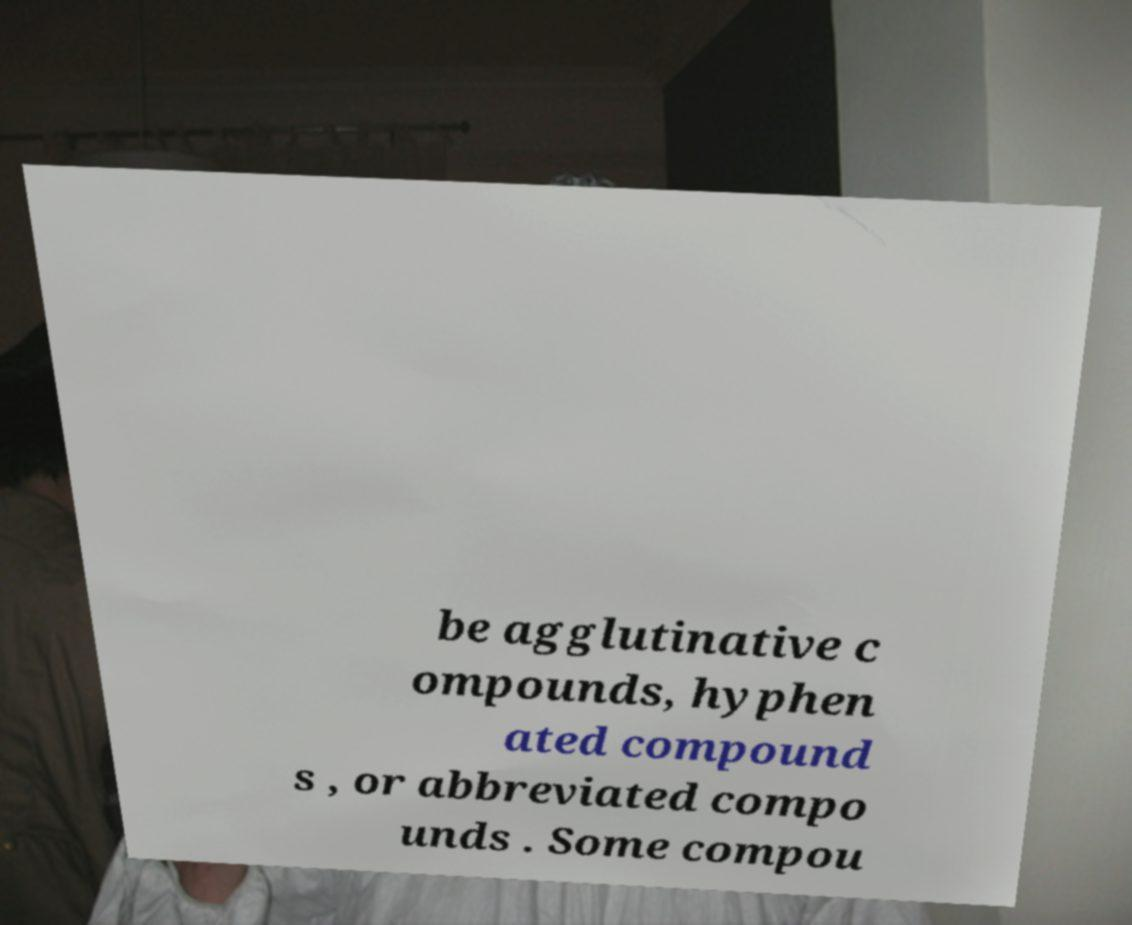Could you extract and type out the text from this image? be agglutinative c ompounds, hyphen ated compound s , or abbreviated compo unds . Some compou 